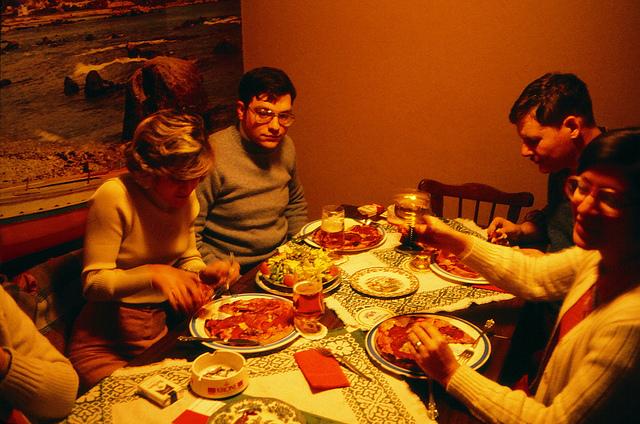Is this a family meal?
Give a very brief answer. Yes. What is on the painting behind the table?
Short answer required. Water. How many people are at the table?
Answer briefly. 5. 